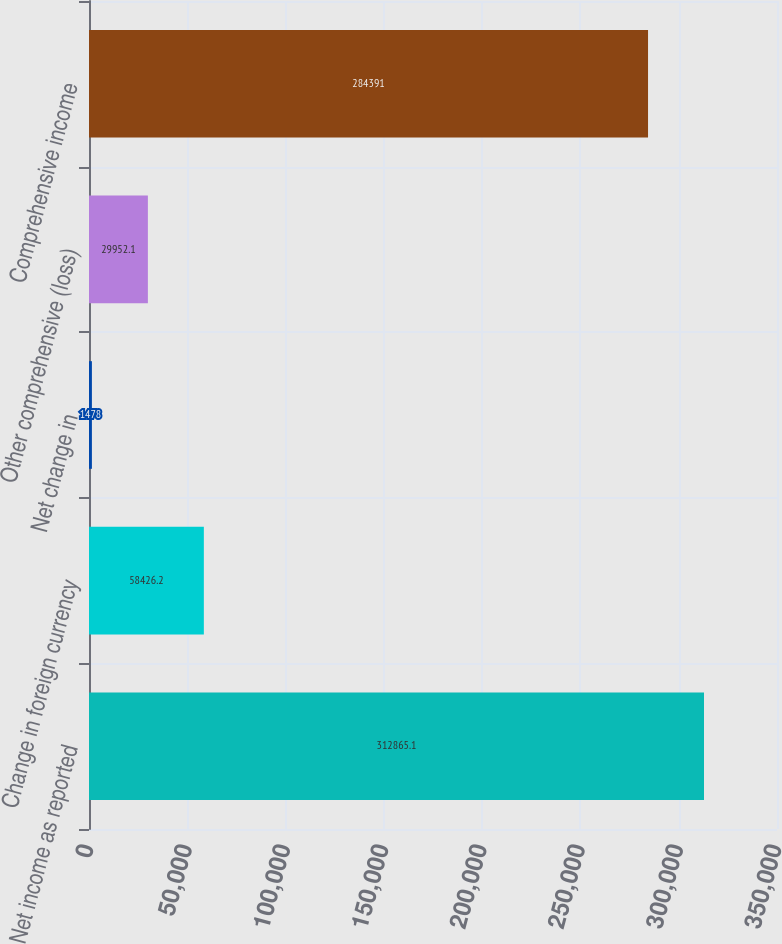Convert chart to OTSL. <chart><loc_0><loc_0><loc_500><loc_500><bar_chart><fcel>Net income as reported<fcel>Change in foreign currency<fcel>Net change in<fcel>Other comprehensive (loss)<fcel>Comprehensive income<nl><fcel>312865<fcel>58426.2<fcel>1478<fcel>29952.1<fcel>284391<nl></chart> 